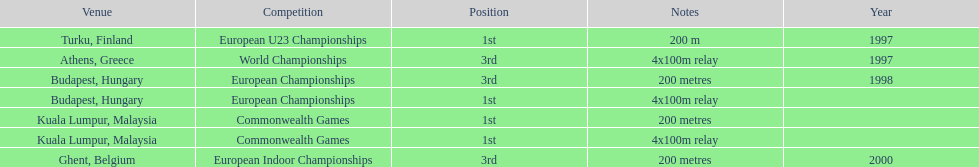In what year did england get the top achievment in the 200 meter? 1997. 